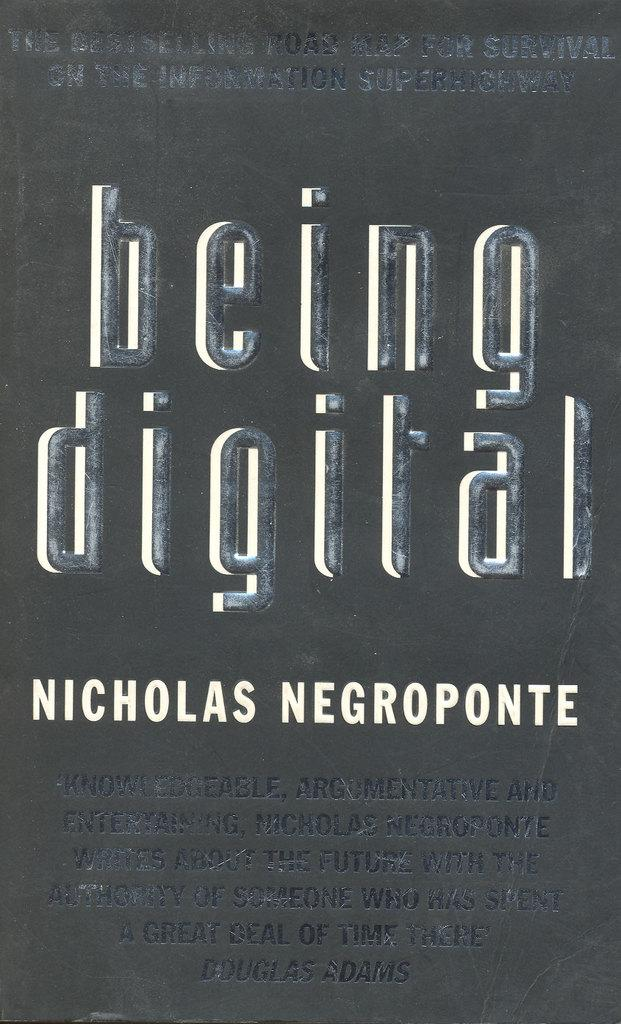<image>
Relay a brief, clear account of the picture shown. The cover of a book by Nicolas Negroponte 